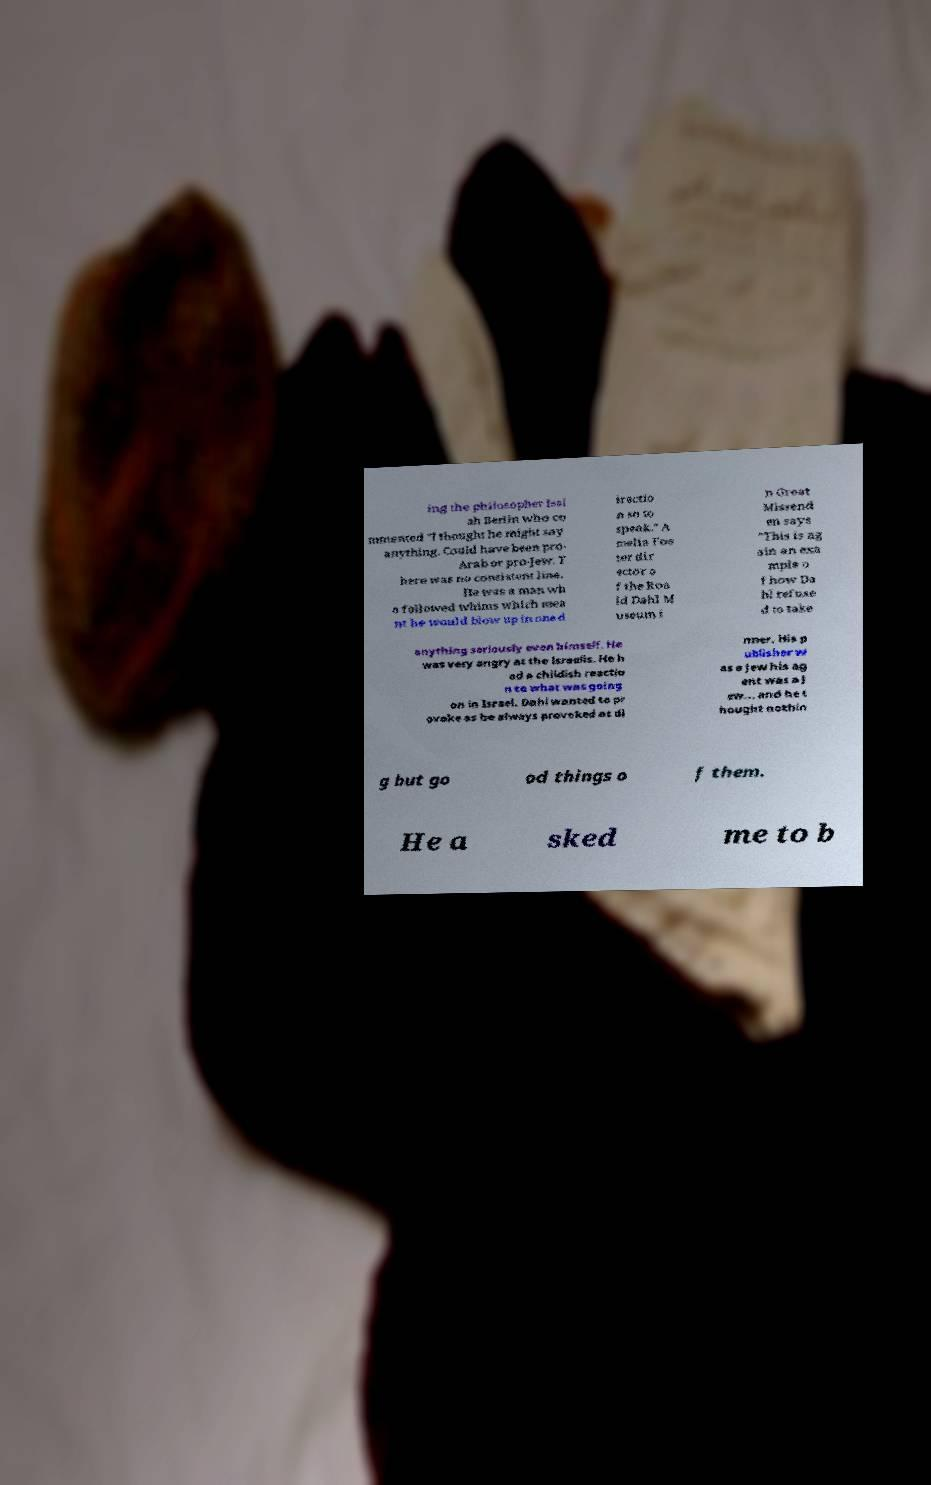Could you assist in decoding the text presented in this image and type it out clearly? ing the philosopher Isai ah Berlin who co mmented "I thought he might say anything. Could have been pro- Arab or pro-Jew. T here was no consistent line. He was a man wh o followed whims which mea nt he would blow up in one d irectio n so to speak." A melia Fos ter dir ector o f the Roa ld Dahl M useum i n Great Missend en says "This is ag ain an exa mple o f how Da hl refuse d to take anything seriously even himself. He was very angry at the Israelis. He h ad a childish reactio n to what was going on in Israel. Dahl wanted to pr ovoke as he always provoked at di nner. His p ublisher w as a Jew his ag ent was a J ew... and he t hought nothin g but go od things o f them. He a sked me to b 